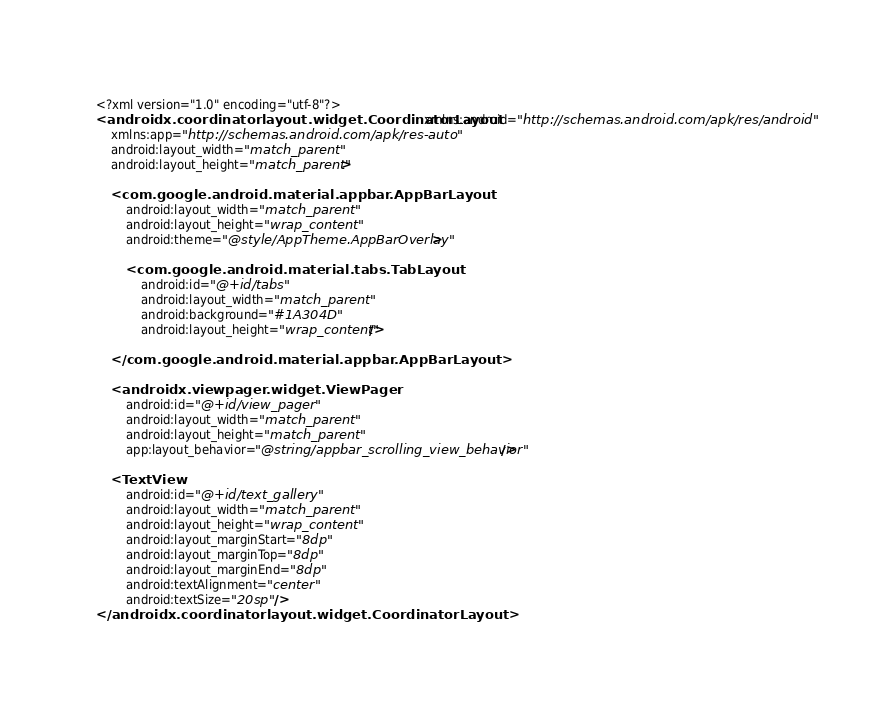<code> <loc_0><loc_0><loc_500><loc_500><_XML_><?xml version="1.0" encoding="utf-8"?>
<androidx.coordinatorlayout.widget.CoordinatorLayout xmlns:android="http://schemas.android.com/apk/res/android"
    xmlns:app="http://schemas.android.com/apk/res-auto"
    android:layout_width="match_parent"
    android:layout_height="match_parent">

    <com.google.android.material.appbar.AppBarLayout
        android:layout_width="match_parent"
        android:layout_height="wrap_content"
        android:theme="@style/AppTheme.AppBarOverlay">

        <com.google.android.material.tabs.TabLayout
            android:id="@+id/tabs"
            android:layout_width="match_parent"
            android:background="#1A304D"
            android:layout_height="wrap_content"/>

    </com.google.android.material.appbar.AppBarLayout>

    <androidx.viewpager.widget.ViewPager
        android:id="@+id/view_pager"
        android:layout_width="match_parent"
        android:layout_height="match_parent"
        app:layout_behavior="@string/appbar_scrolling_view_behavior"/>

    <TextView
        android:id="@+id/text_gallery"
        android:layout_width="match_parent"
        android:layout_height="wrap_content"
        android:layout_marginStart="8dp"
        android:layout_marginTop="8dp"
        android:layout_marginEnd="8dp"
        android:textAlignment="center"
        android:textSize="20sp" />
</androidx.coordinatorlayout.widget.CoordinatorLayout></code> 